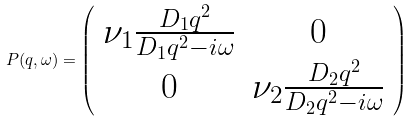<formula> <loc_0><loc_0><loc_500><loc_500>P ( q , \omega ) = \left ( \begin{array} { c c } \nu _ { 1 } \frac { D _ { 1 } q ^ { 2 } } { D _ { 1 } q ^ { 2 } - i \omega } & 0 \\ 0 & \nu _ { 2 } \frac { D _ { 2 } q ^ { 2 } } { D _ { 2 } q ^ { 2 } - i \omega } \\ \end{array} \right )</formula> 